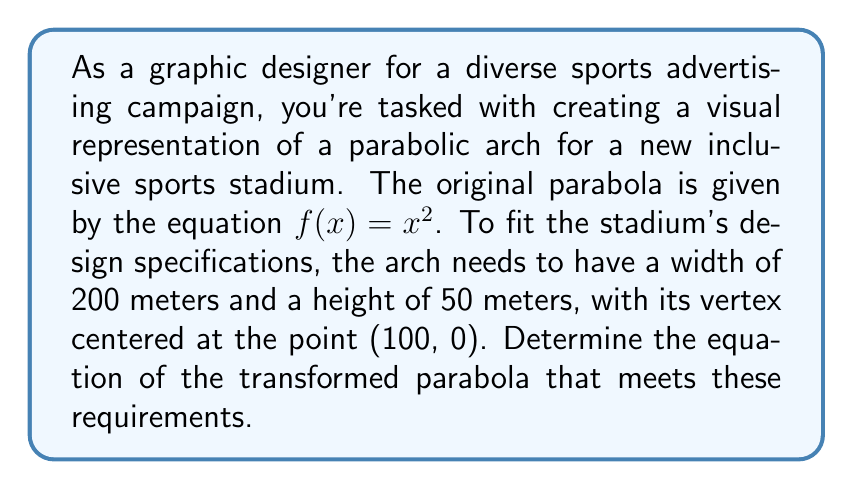Could you help me with this problem? To solve this problem, we need to apply scaling and translation transformations to the original parabola. Let's break it down step-by-step:

1. Start with the original parabola: $f(x) = x^2$

2. Scale horizontally:
   The width needs to be 200 meters, so the parabola should extend from x = 0 to x = 200.
   This means we need to compress the x-axis by a factor of $\frac{1}{100}$.
   Apply the transformation: $f(x) = (\frac{x}{100})^2$

3. Scale vertically:
   The height should be 50 meters when x = 100 (at the edges of the parabola).
   At x = 100, the current height is $(\frac{100}{100})^2 = 1$.
   We need to scale this to 50, so multiply by 50.
   Apply the transformation: $f(x) = 50(\frac{x}{100})^2$

4. Translate horizontally:
   The vertex needs to be at x = 100, so shift 100 units to the right.
   Apply the transformation: $f(x) = 50(\frac{x-100}{100})^2$

5. Translate vertically:
   The vertex needs to be at y = 0, so no vertical translation is needed.

6. Simplify the equation:
   $f(x) = 50(\frac{x-100}{100})^2$
   $f(x) = 50(\frac{1}{10000})(x-100)^2$
   $f(x) = \frac{1}{200}(x-100)^2$

The final equation represents a parabola that is 200 meters wide, 50 meters tall, and centered at (100, 0).
Answer: The equation of the transformed parabola is:

$$f(x) = \frac{1}{200}(x-100)^2$$ 